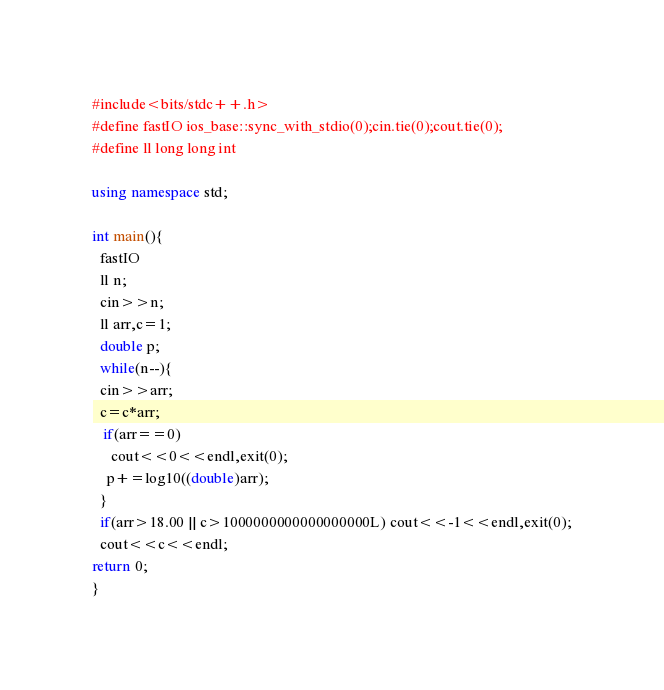Convert code to text. <code><loc_0><loc_0><loc_500><loc_500><_C++_>#include<bits/stdc++.h>
#define fastIO ios_base::sync_with_stdio(0);cin.tie(0);cout.tie(0);
#define ll long long int

using namespace std;

int main(){
  fastIO
  ll n;
  cin>>n;
  ll arr,c=1;
  double p;
  while(n--){
  cin>>arr;
  c=c*arr;
   if(arr==0)
     cout<<0<<endl,exit(0);
    p+=log10((double)arr);
  }
  if(arr>18.00 || c>1000000000000000000L) cout<<-1<<endl,exit(0);
  cout<<c<<endl;
return 0;
}
</code> 